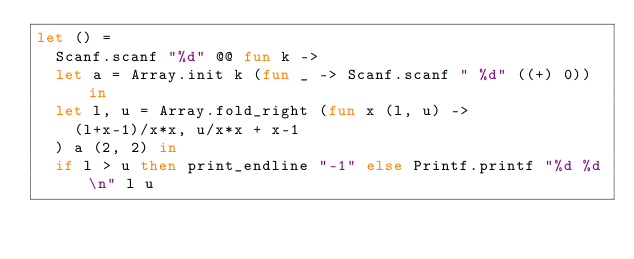<code> <loc_0><loc_0><loc_500><loc_500><_OCaml_>let () =
  Scanf.scanf "%d" @@ fun k ->
  let a = Array.init k (fun _ -> Scanf.scanf " %d" ((+) 0)) in
  let l, u = Array.fold_right (fun x (l, u) ->
    (l+x-1)/x*x, u/x*x + x-1
  ) a (2, 2) in
  if l > u then print_endline "-1" else Printf.printf "%d %d\n" l u</code> 